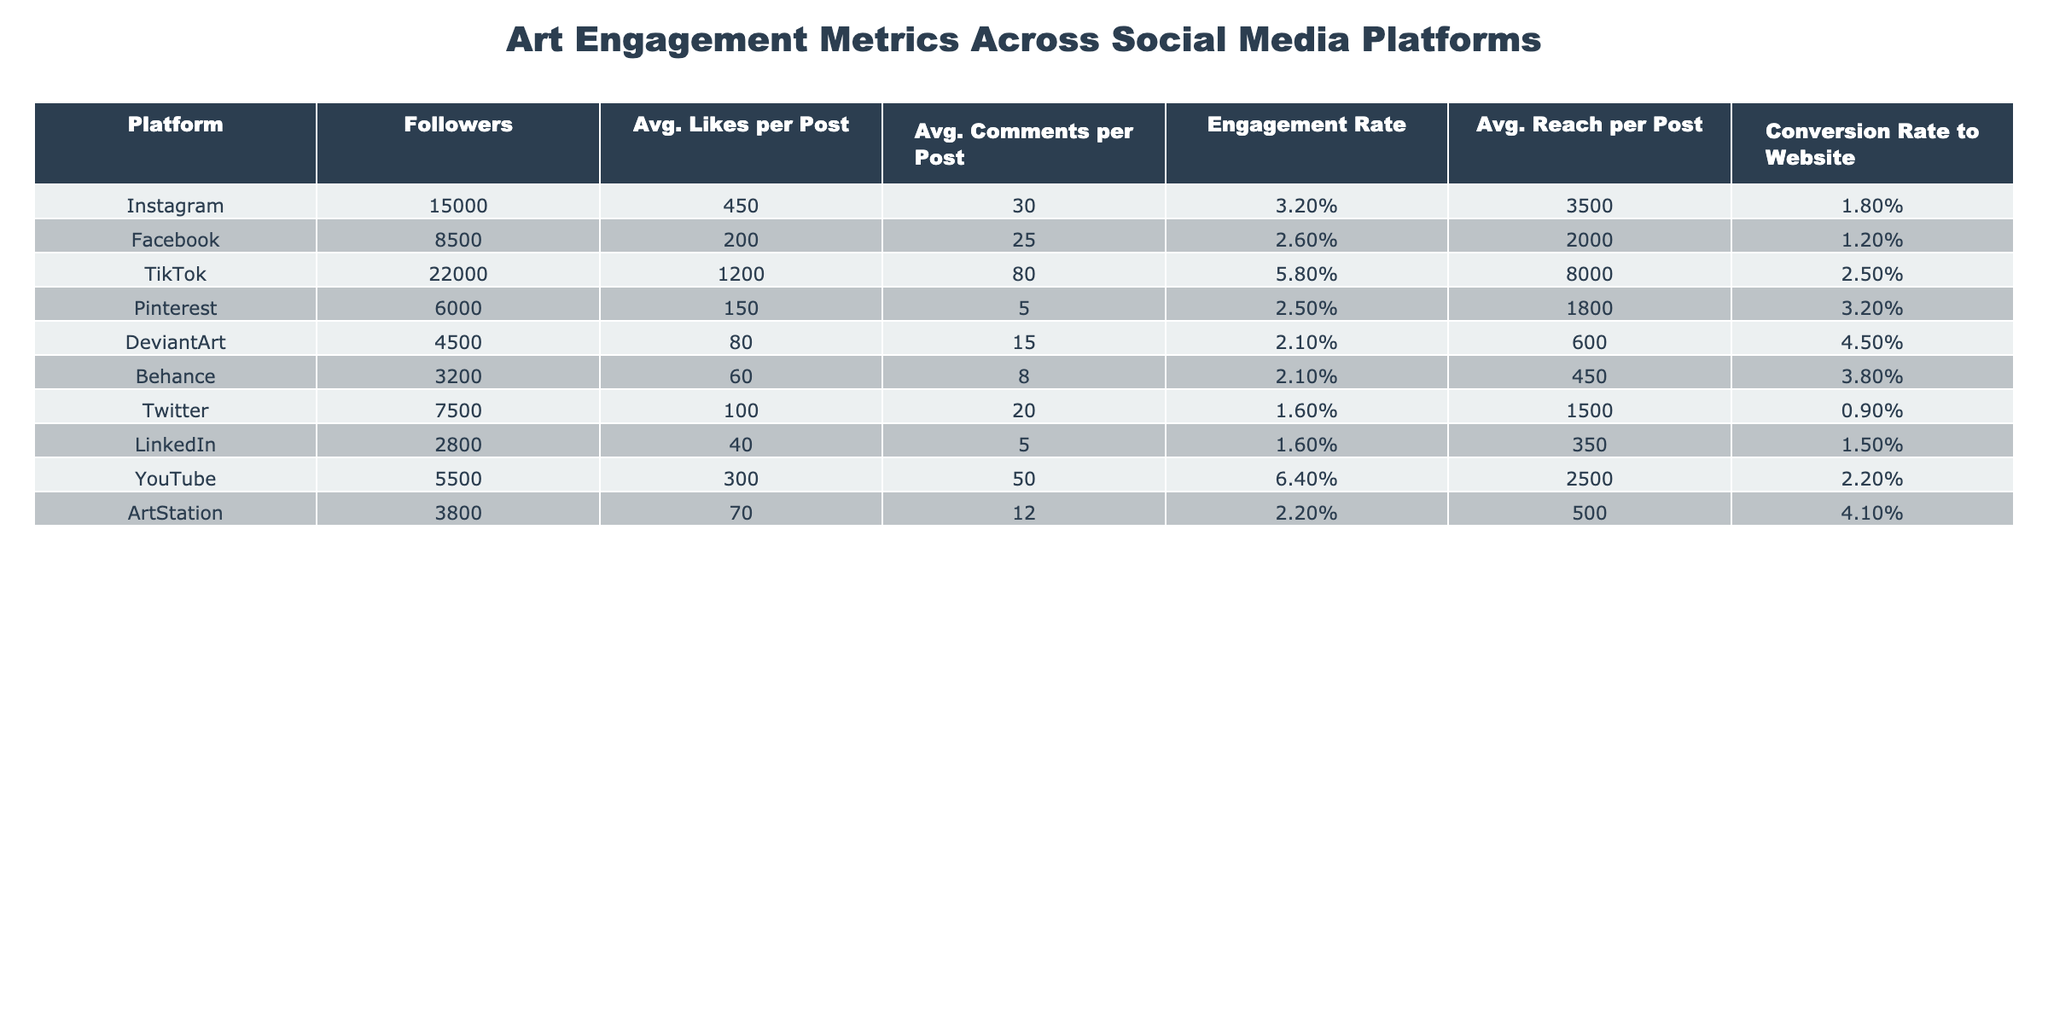What is the engagement rate for TikTok? Looking at the table, the engagement rate for TikTok is explicitly listed as 5.8%.
Answer: 5.8% Which platform has the highest average likes per post? The table shows that TikTok has the highest average likes per post at 1200.
Answer: 1200 What is the average reach per post for Instagram? Referring to the table, the average reach per post for Instagram is 3500.
Answer: 3500 Is the conversion rate to the website for DeviantArt higher than that for LinkedIn? Comparing the conversion rates, DeviantArt's rate is 4.5% while LinkedIn's is 1.5%, so true.
Answer: Yes What is the average engagement rate for all platforms combined? To find the average, add all engagement rates: (3.2% + 2.6% + 5.8% + 2.5% + 2.1% + 2.1% + 1.6% + 1.6% + 6.4% + 2.2%) = 30.2%. Dividing by the number of platforms (10): 30.2% / 10 = 3.02%.
Answer: 3.02% Which platform has the least number of followers? The table indicates that Behance has the least number of followers at 3200.
Answer: 3200 What is the difference in average likes per post between TikTok and Instagram? The average likes per post for TikTok is 1200 and for Instagram is 450, so the difference is 1200 - 450 = 750.
Answer: 750 Is the average comments per post for YouTube greater than the average comments for Facebook? YouTube has an average of 50 comments per post compared to Facebook's 25, therefore true.
Answer: Yes If you add the followers from Pinterest and DeviantArt, how many followers do they have together? Adding Pinterest's 6000 followers and DeviantArt's 4500 followers results in 6000 + 4500 = 10500.
Answer: 10500 Which platform has a conversion rate equal to or greater than 2%? Checking the table, platforms with a conversion rate of 2% or higher include TikTok (2.5%), Pinterest (3.2%), DeviantArt (4.5%), YouTube (2.2%), and ArtStation (4.1%).
Answer: TikTok, Pinterest, DeviantArt, YouTube, ArtStation What is the total average comments per post for Facebook and Twitter combined? The average comments for Facebook is 25 and for Twitter is 20. Adding these gives 25 + 20 = 45.
Answer: 45 